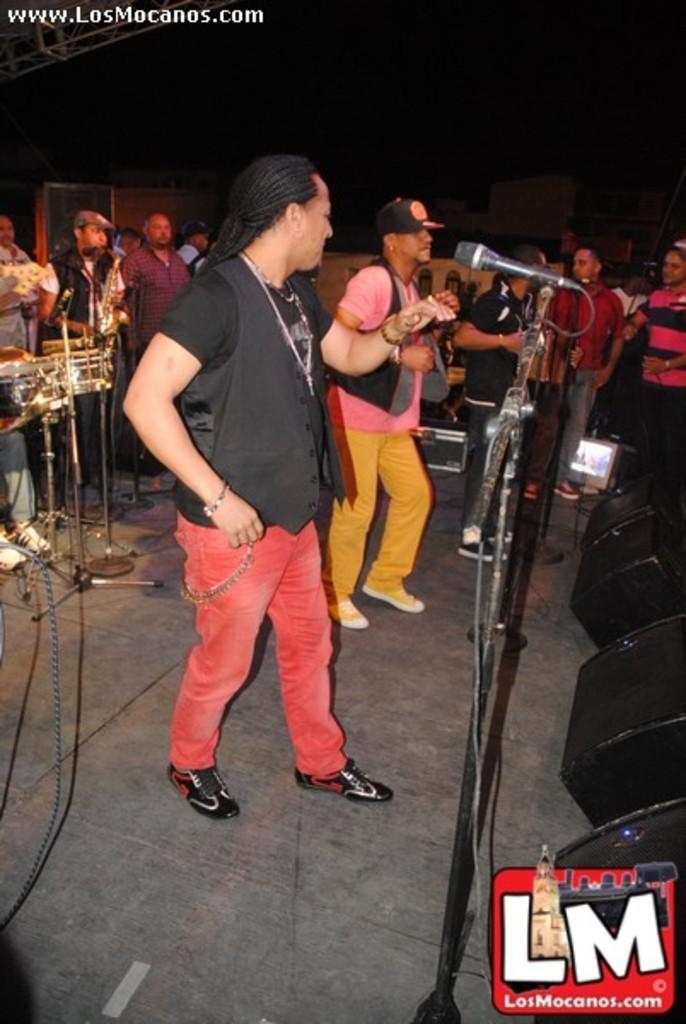What are the persons in the image doing? The persons in the image are playing musical instruments. What objects are present to amplify the sound of their instruments? There are microphones in the image. Can you describe the people in the image? There are persons standing in the image. Where are the sound boxes located in the image? The sound boxes are on the right side of the image. What type of chair can be seen in the image? There is no chair present in the image. What kind of beast is interacting with the sound boxes in the image? There is no beast present in the image; only the sound boxes and people playing musical instruments are visible. 